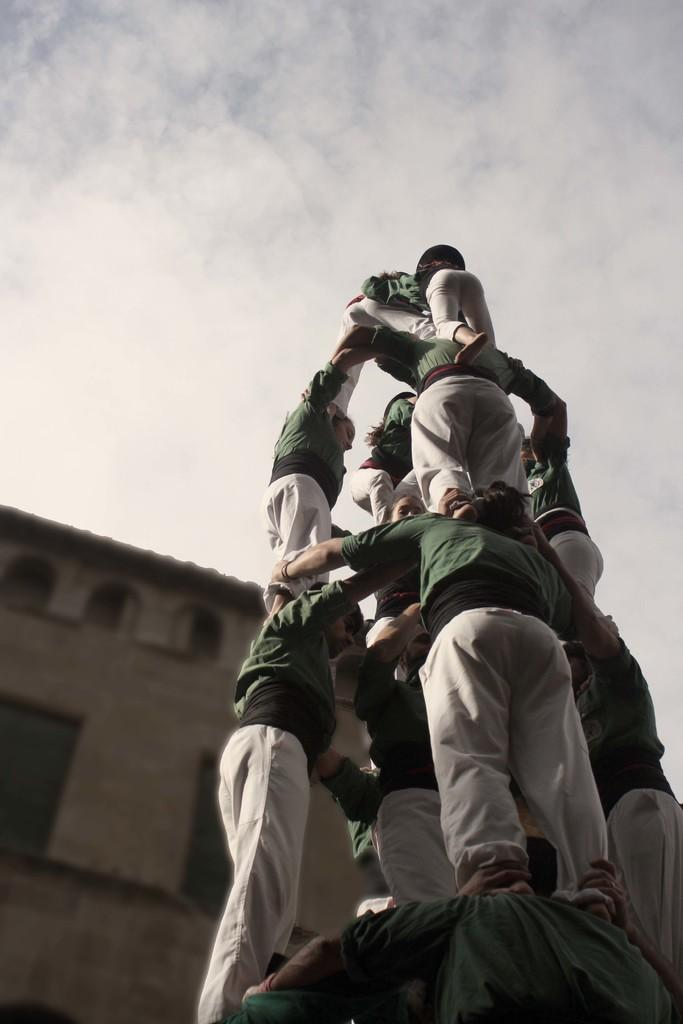What are the people in the image doing? The people in the image are standing one upon another. What can be seen in the background of the image? There is a building visible in the image. How would you describe the weather in the image? The sky is cloudy in the image. What type of story is being told by the cattle in the image? There are no cattle present in the image, so no story can be told by them. 